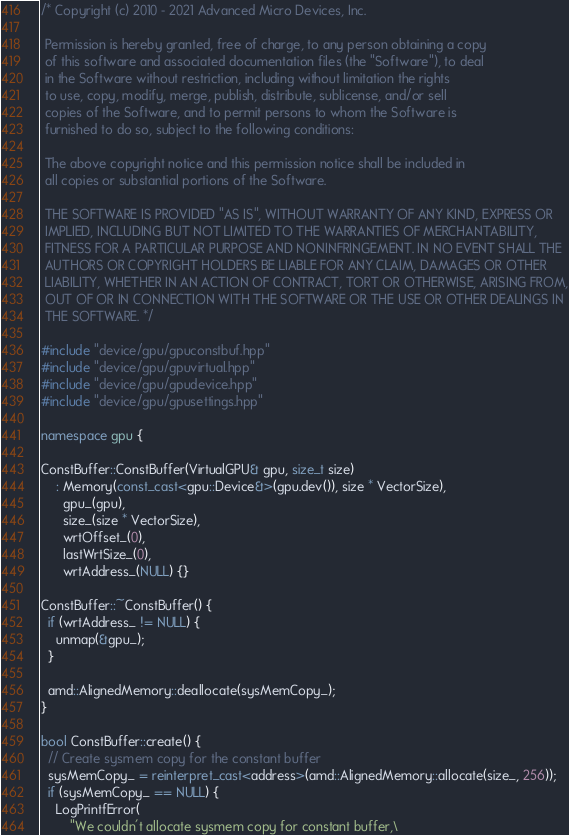Convert code to text. <code><loc_0><loc_0><loc_500><loc_500><_C++_>/* Copyright (c) 2010 - 2021 Advanced Micro Devices, Inc.

 Permission is hereby granted, free of charge, to any person obtaining a copy
 of this software and associated documentation files (the "Software"), to deal
 in the Software without restriction, including without limitation the rights
 to use, copy, modify, merge, publish, distribute, sublicense, and/or sell
 copies of the Software, and to permit persons to whom the Software is
 furnished to do so, subject to the following conditions:

 The above copyright notice and this permission notice shall be included in
 all copies or substantial portions of the Software.

 THE SOFTWARE IS PROVIDED "AS IS", WITHOUT WARRANTY OF ANY KIND, EXPRESS OR
 IMPLIED, INCLUDING BUT NOT LIMITED TO THE WARRANTIES OF MERCHANTABILITY,
 FITNESS FOR A PARTICULAR PURPOSE AND NONINFRINGEMENT. IN NO EVENT SHALL THE
 AUTHORS OR COPYRIGHT HOLDERS BE LIABLE FOR ANY CLAIM, DAMAGES OR OTHER
 LIABILITY, WHETHER IN AN ACTION OF CONTRACT, TORT OR OTHERWISE, ARISING FROM,
 OUT OF OR IN CONNECTION WITH THE SOFTWARE OR THE USE OR OTHER DEALINGS IN
 THE SOFTWARE. */

#include "device/gpu/gpuconstbuf.hpp"
#include "device/gpu/gpuvirtual.hpp"
#include "device/gpu/gpudevice.hpp"
#include "device/gpu/gpusettings.hpp"

namespace gpu {

ConstBuffer::ConstBuffer(VirtualGPU& gpu, size_t size)
    : Memory(const_cast<gpu::Device&>(gpu.dev()), size * VectorSize),
      gpu_(gpu),
      size_(size * VectorSize),
      wrtOffset_(0),
      lastWrtSize_(0),
      wrtAddress_(NULL) {}

ConstBuffer::~ConstBuffer() {
  if (wrtAddress_ != NULL) {
    unmap(&gpu_);
  }

  amd::AlignedMemory::deallocate(sysMemCopy_);
}

bool ConstBuffer::create() {
  // Create sysmem copy for the constant buffer
  sysMemCopy_ = reinterpret_cast<address>(amd::AlignedMemory::allocate(size_, 256));
  if (sysMemCopy_ == NULL) {
    LogPrintfError(
        "We couldn't allocate sysmem copy for constant buffer,\</code> 